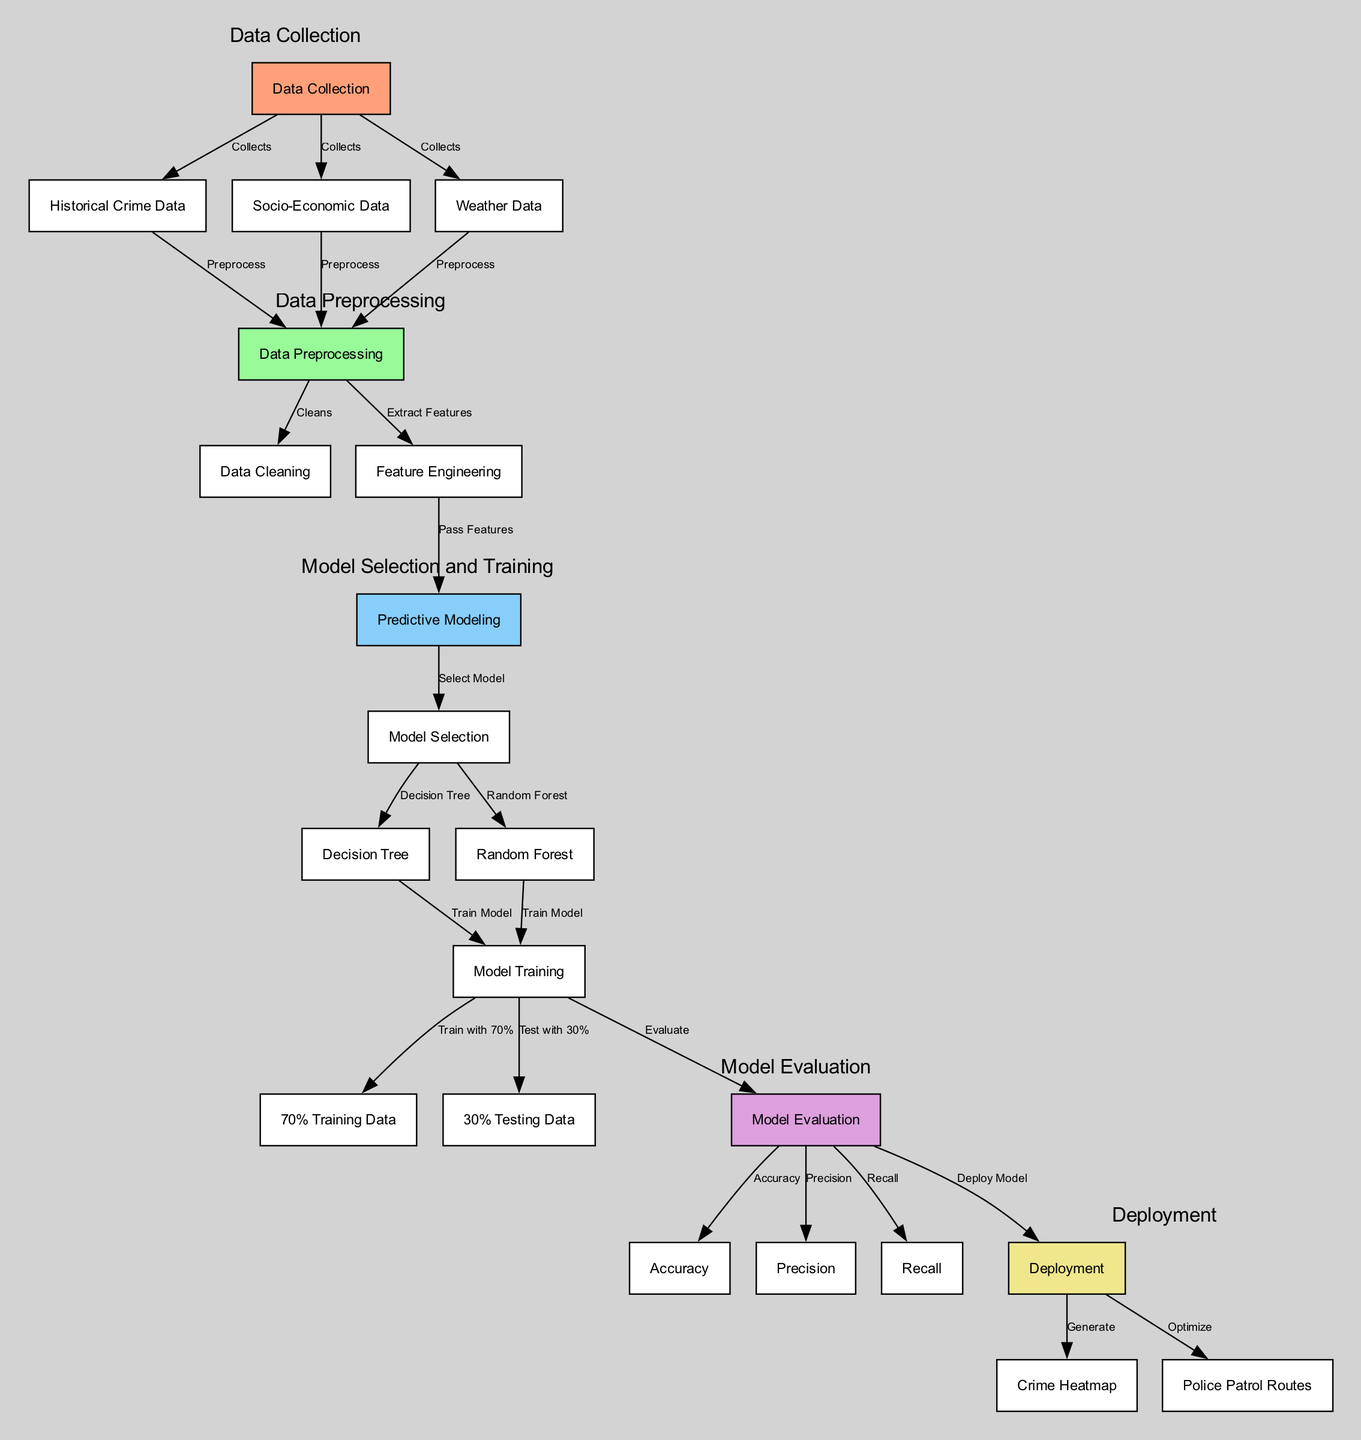What is the first step of the Predictive Policing Model? The first step is "Data Collection" which collects various types of data including historical crime data, socio-economic data, and weather data.
Answer: Data Collection How many nodes are in the diagram? By counting all the nodes listed, there are 19 nodes in total including data collection, data preprocessing, predictive modeling, etc.
Answer: 19 Which node generates a crime heatmap? The "Deployment" node is responsible for generating the "Crime Heatmap".
Answer: Crime Heatmap What types of models are selected in the model selection phase? In the model selection phase, "Decision Tree" and "Random Forest" models are selected as indicated by the edges leading to these nodes.
Answer: Decision Tree, Random Forest What is the purpose of the "Model Evaluation" node? The "Model Evaluation" node assesses the performance of the models based on metrics such as accuracy, precision, and recall before deployment.
Answer: Evaluate Models How is the data split for training and testing? The data is split with 70% allocated for training and 30% for testing, as indicated by the edges from "Model Training" to these nodes.
Answer: 70% Training Data, 30% Testing Data Which node follows "Feature Engineering"? The "Predictive Modeling" node follows "Feature Engineering", indicating the transition to model selection and training.
Answer: Predictive Modeling What does the "Police Patrol Routes" node optimize? The "Police Patrol Routes" node optimizes the patrol routes for law enforcement based on insights derived from the predictive model.
Answer: Optimize Patrol Routes 